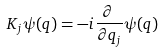Convert formula to latex. <formula><loc_0><loc_0><loc_500><loc_500>K _ { j } \psi ( q ) = - i \frac { \partial \, } { \partial q _ { j } } \psi ( q )</formula> 